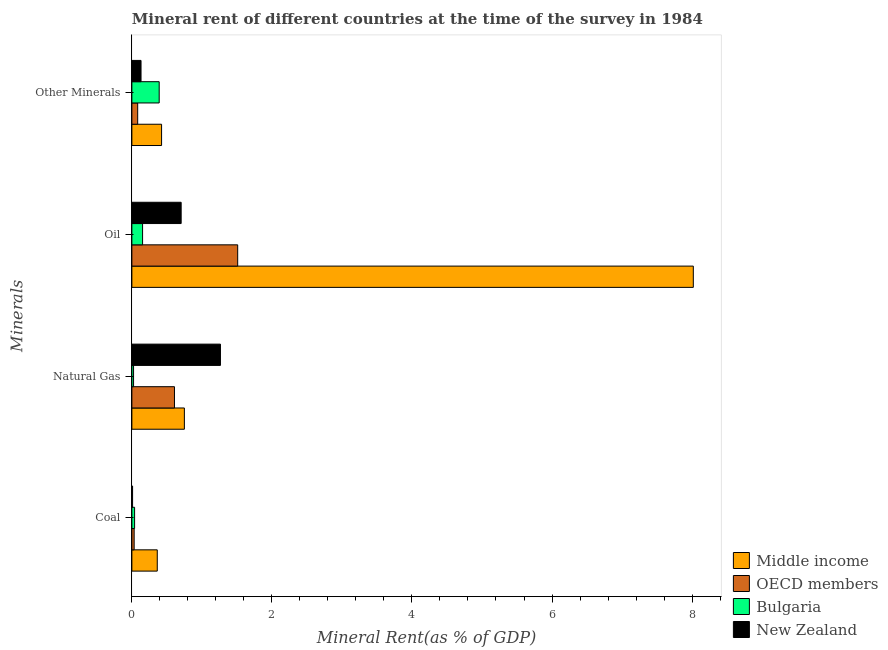How many different coloured bars are there?
Provide a short and direct response. 4. How many groups of bars are there?
Provide a short and direct response. 4. Are the number of bars per tick equal to the number of legend labels?
Ensure brevity in your answer.  Yes. Are the number of bars on each tick of the Y-axis equal?
Offer a very short reply. Yes. What is the label of the 1st group of bars from the top?
Your answer should be compact. Other Minerals. What is the  rent of other minerals in OECD members?
Your answer should be very brief. 0.08. Across all countries, what is the maximum coal rent?
Give a very brief answer. 0.36. Across all countries, what is the minimum  rent of other minerals?
Ensure brevity in your answer.  0.08. In which country was the natural gas rent maximum?
Ensure brevity in your answer.  New Zealand. In which country was the oil rent minimum?
Keep it short and to the point. Bulgaria. What is the total oil rent in the graph?
Offer a terse response. 10.39. What is the difference between the natural gas rent in Bulgaria and that in New Zealand?
Give a very brief answer. -1.24. What is the difference between the oil rent in OECD members and the natural gas rent in New Zealand?
Offer a terse response. 0.25. What is the average coal rent per country?
Provide a short and direct response. 0.11. What is the difference between the natural gas rent and coal rent in OECD members?
Provide a short and direct response. 0.58. What is the ratio of the oil rent in OECD members to that in New Zealand?
Give a very brief answer. 2.15. Is the natural gas rent in New Zealand less than that in Middle income?
Make the answer very short. No. Is the difference between the oil rent in Bulgaria and New Zealand greater than the difference between the natural gas rent in Bulgaria and New Zealand?
Offer a very short reply. Yes. What is the difference between the highest and the second highest coal rent?
Your response must be concise. 0.32. What is the difference between the highest and the lowest oil rent?
Offer a very short reply. 7.87. What does the 1st bar from the top in Oil represents?
Make the answer very short. New Zealand. Is it the case that in every country, the sum of the coal rent and natural gas rent is greater than the oil rent?
Provide a short and direct response. No. How many countries are there in the graph?
Your response must be concise. 4. Does the graph contain grids?
Your response must be concise. No. Where does the legend appear in the graph?
Give a very brief answer. Bottom right. How many legend labels are there?
Your answer should be very brief. 4. What is the title of the graph?
Provide a succinct answer. Mineral rent of different countries at the time of the survey in 1984. What is the label or title of the X-axis?
Provide a short and direct response. Mineral Rent(as % of GDP). What is the label or title of the Y-axis?
Your answer should be compact. Minerals. What is the Mineral Rent(as % of GDP) of Middle income in Coal?
Your answer should be very brief. 0.36. What is the Mineral Rent(as % of GDP) of OECD members in Coal?
Provide a short and direct response. 0.03. What is the Mineral Rent(as % of GDP) in Bulgaria in Coal?
Provide a succinct answer. 0.04. What is the Mineral Rent(as % of GDP) in New Zealand in Coal?
Make the answer very short. 0.01. What is the Mineral Rent(as % of GDP) in Middle income in Natural Gas?
Provide a succinct answer. 0.75. What is the Mineral Rent(as % of GDP) of OECD members in Natural Gas?
Your answer should be very brief. 0.61. What is the Mineral Rent(as % of GDP) in Bulgaria in Natural Gas?
Your answer should be very brief. 0.02. What is the Mineral Rent(as % of GDP) of New Zealand in Natural Gas?
Ensure brevity in your answer.  1.26. What is the Mineral Rent(as % of GDP) in Middle income in Oil?
Keep it short and to the point. 8.02. What is the Mineral Rent(as % of GDP) in OECD members in Oil?
Give a very brief answer. 1.51. What is the Mineral Rent(as % of GDP) of Bulgaria in Oil?
Provide a succinct answer. 0.15. What is the Mineral Rent(as % of GDP) in New Zealand in Oil?
Make the answer very short. 0.7. What is the Mineral Rent(as % of GDP) in Middle income in Other Minerals?
Keep it short and to the point. 0.42. What is the Mineral Rent(as % of GDP) in OECD members in Other Minerals?
Offer a very short reply. 0.08. What is the Mineral Rent(as % of GDP) of Bulgaria in Other Minerals?
Keep it short and to the point. 0.39. What is the Mineral Rent(as % of GDP) of New Zealand in Other Minerals?
Ensure brevity in your answer.  0.13. Across all Minerals, what is the maximum Mineral Rent(as % of GDP) in Middle income?
Your response must be concise. 8.02. Across all Minerals, what is the maximum Mineral Rent(as % of GDP) in OECD members?
Offer a very short reply. 1.51. Across all Minerals, what is the maximum Mineral Rent(as % of GDP) in Bulgaria?
Keep it short and to the point. 0.39. Across all Minerals, what is the maximum Mineral Rent(as % of GDP) in New Zealand?
Ensure brevity in your answer.  1.26. Across all Minerals, what is the minimum Mineral Rent(as % of GDP) in Middle income?
Offer a very short reply. 0.36. Across all Minerals, what is the minimum Mineral Rent(as % of GDP) of OECD members?
Give a very brief answer. 0.03. Across all Minerals, what is the minimum Mineral Rent(as % of GDP) in Bulgaria?
Your response must be concise. 0.02. Across all Minerals, what is the minimum Mineral Rent(as % of GDP) of New Zealand?
Keep it short and to the point. 0.01. What is the total Mineral Rent(as % of GDP) of Middle income in the graph?
Provide a succinct answer. 9.55. What is the total Mineral Rent(as % of GDP) in OECD members in the graph?
Offer a very short reply. 2.24. What is the total Mineral Rent(as % of GDP) in Bulgaria in the graph?
Keep it short and to the point. 0.61. What is the total Mineral Rent(as % of GDP) in New Zealand in the graph?
Ensure brevity in your answer.  2.11. What is the difference between the Mineral Rent(as % of GDP) in Middle income in Coal and that in Natural Gas?
Offer a very short reply. -0.39. What is the difference between the Mineral Rent(as % of GDP) of OECD members in Coal and that in Natural Gas?
Offer a terse response. -0.58. What is the difference between the Mineral Rent(as % of GDP) of Bulgaria in Coal and that in Natural Gas?
Provide a short and direct response. 0.01. What is the difference between the Mineral Rent(as % of GDP) in New Zealand in Coal and that in Natural Gas?
Your answer should be compact. -1.25. What is the difference between the Mineral Rent(as % of GDP) in Middle income in Coal and that in Oil?
Your answer should be compact. -7.66. What is the difference between the Mineral Rent(as % of GDP) of OECD members in Coal and that in Oil?
Your answer should be compact. -1.48. What is the difference between the Mineral Rent(as % of GDP) of Bulgaria in Coal and that in Oil?
Your response must be concise. -0.11. What is the difference between the Mineral Rent(as % of GDP) in New Zealand in Coal and that in Oil?
Your answer should be very brief. -0.69. What is the difference between the Mineral Rent(as % of GDP) of Middle income in Coal and that in Other Minerals?
Offer a terse response. -0.06. What is the difference between the Mineral Rent(as % of GDP) in OECD members in Coal and that in Other Minerals?
Ensure brevity in your answer.  -0.05. What is the difference between the Mineral Rent(as % of GDP) of Bulgaria in Coal and that in Other Minerals?
Provide a short and direct response. -0.35. What is the difference between the Mineral Rent(as % of GDP) in New Zealand in Coal and that in Other Minerals?
Provide a succinct answer. -0.12. What is the difference between the Mineral Rent(as % of GDP) of Middle income in Natural Gas and that in Oil?
Provide a succinct answer. -7.27. What is the difference between the Mineral Rent(as % of GDP) of OECD members in Natural Gas and that in Oil?
Make the answer very short. -0.9. What is the difference between the Mineral Rent(as % of GDP) of Bulgaria in Natural Gas and that in Oil?
Provide a succinct answer. -0.13. What is the difference between the Mineral Rent(as % of GDP) in New Zealand in Natural Gas and that in Oil?
Your response must be concise. 0.56. What is the difference between the Mineral Rent(as % of GDP) of Middle income in Natural Gas and that in Other Minerals?
Ensure brevity in your answer.  0.33. What is the difference between the Mineral Rent(as % of GDP) in OECD members in Natural Gas and that in Other Minerals?
Keep it short and to the point. 0.53. What is the difference between the Mineral Rent(as % of GDP) of Bulgaria in Natural Gas and that in Other Minerals?
Ensure brevity in your answer.  -0.37. What is the difference between the Mineral Rent(as % of GDP) in New Zealand in Natural Gas and that in Other Minerals?
Your response must be concise. 1.13. What is the difference between the Mineral Rent(as % of GDP) in Middle income in Oil and that in Other Minerals?
Provide a short and direct response. 7.59. What is the difference between the Mineral Rent(as % of GDP) in OECD members in Oil and that in Other Minerals?
Offer a very short reply. 1.43. What is the difference between the Mineral Rent(as % of GDP) in Bulgaria in Oil and that in Other Minerals?
Provide a short and direct response. -0.24. What is the difference between the Mineral Rent(as % of GDP) in New Zealand in Oil and that in Other Minerals?
Your answer should be compact. 0.57. What is the difference between the Mineral Rent(as % of GDP) in Middle income in Coal and the Mineral Rent(as % of GDP) in OECD members in Natural Gas?
Ensure brevity in your answer.  -0.25. What is the difference between the Mineral Rent(as % of GDP) in Middle income in Coal and the Mineral Rent(as % of GDP) in Bulgaria in Natural Gas?
Your answer should be very brief. 0.34. What is the difference between the Mineral Rent(as % of GDP) in Middle income in Coal and the Mineral Rent(as % of GDP) in New Zealand in Natural Gas?
Provide a short and direct response. -0.9. What is the difference between the Mineral Rent(as % of GDP) of OECD members in Coal and the Mineral Rent(as % of GDP) of Bulgaria in Natural Gas?
Offer a terse response. 0.01. What is the difference between the Mineral Rent(as % of GDP) of OECD members in Coal and the Mineral Rent(as % of GDP) of New Zealand in Natural Gas?
Offer a terse response. -1.23. What is the difference between the Mineral Rent(as % of GDP) in Bulgaria in Coal and the Mineral Rent(as % of GDP) in New Zealand in Natural Gas?
Provide a short and direct response. -1.23. What is the difference between the Mineral Rent(as % of GDP) in Middle income in Coal and the Mineral Rent(as % of GDP) in OECD members in Oil?
Offer a terse response. -1.15. What is the difference between the Mineral Rent(as % of GDP) of Middle income in Coal and the Mineral Rent(as % of GDP) of Bulgaria in Oil?
Provide a short and direct response. 0.21. What is the difference between the Mineral Rent(as % of GDP) of Middle income in Coal and the Mineral Rent(as % of GDP) of New Zealand in Oil?
Offer a terse response. -0.34. What is the difference between the Mineral Rent(as % of GDP) of OECD members in Coal and the Mineral Rent(as % of GDP) of Bulgaria in Oil?
Offer a very short reply. -0.12. What is the difference between the Mineral Rent(as % of GDP) of OECD members in Coal and the Mineral Rent(as % of GDP) of New Zealand in Oil?
Your response must be concise. -0.67. What is the difference between the Mineral Rent(as % of GDP) in Bulgaria in Coal and the Mineral Rent(as % of GDP) in New Zealand in Oil?
Provide a succinct answer. -0.66. What is the difference between the Mineral Rent(as % of GDP) in Middle income in Coal and the Mineral Rent(as % of GDP) in OECD members in Other Minerals?
Ensure brevity in your answer.  0.28. What is the difference between the Mineral Rent(as % of GDP) of Middle income in Coal and the Mineral Rent(as % of GDP) of Bulgaria in Other Minerals?
Offer a terse response. -0.03. What is the difference between the Mineral Rent(as % of GDP) in Middle income in Coal and the Mineral Rent(as % of GDP) in New Zealand in Other Minerals?
Your answer should be very brief. 0.23. What is the difference between the Mineral Rent(as % of GDP) of OECD members in Coal and the Mineral Rent(as % of GDP) of Bulgaria in Other Minerals?
Offer a terse response. -0.36. What is the difference between the Mineral Rent(as % of GDP) in OECD members in Coal and the Mineral Rent(as % of GDP) in New Zealand in Other Minerals?
Offer a very short reply. -0.1. What is the difference between the Mineral Rent(as % of GDP) of Bulgaria in Coal and the Mineral Rent(as % of GDP) of New Zealand in Other Minerals?
Offer a terse response. -0.09. What is the difference between the Mineral Rent(as % of GDP) in Middle income in Natural Gas and the Mineral Rent(as % of GDP) in OECD members in Oil?
Your response must be concise. -0.76. What is the difference between the Mineral Rent(as % of GDP) of Middle income in Natural Gas and the Mineral Rent(as % of GDP) of Bulgaria in Oil?
Provide a succinct answer. 0.6. What is the difference between the Mineral Rent(as % of GDP) of Middle income in Natural Gas and the Mineral Rent(as % of GDP) of New Zealand in Oil?
Your answer should be very brief. 0.05. What is the difference between the Mineral Rent(as % of GDP) of OECD members in Natural Gas and the Mineral Rent(as % of GDP) of Bulgaria in Oil?
Keep it short and to the point. 0.46. What is the difference between the Mineral Rent(as % of GDP) of OECD members in Natural Gas and the Mineral Rent(as % of GDP) of New Zealand in Oil?
Keep it short and to the point. -0.1. What is the difference between the Mineral Rent(as % of GDP) of Bulgaria in Natural Gas and the Mineral Rent(as % of GDP) of New Zealand in Oil?
Your answer should be very brief. -0.68. What is the difference between the Mineral Rent(as % of GDP) in Middle income in Natural Gas and the Mineral Rent(as % of GDP) in OECD members in Other Minerals?
Ensure brevity in your answer.  0.67. What is the difference between the Mineral Rent(as % of GDP) of Middle income in Natural Gas and the Mineral Rent(as % of GDP) of Bulgaria in Other Minerals?
Give a very brief answer. 0.36. What is the difference between the Mineral Rent(as % of GDP) in Middle income in Natural Gas and the Mineral Rent(as % of GDP) in New Zealand in Other Minerals?
Your answer should be compact. 0.62. What is the difference between the Mineral Rent(as % of GDP) of OECD members in Natural Gas and the Mineral Rent(as % of GDP) of Bulgaria in Other Minerals?
Give a very brief answer. 0.22. What is the difference between the Mineral Rent(as % of GDP) of OECD members in Natural Gas and the Mineral Rent(as % of GDP) of New Zealand in Other Minerals?
Offer a very short reply. 0.48. What is the difference between the Mineral Rent(as % of GDP) of Bulgaria in Natural Gas and the Mineral Rent(as % of GDP) of New Zealand in Other Minerals?
Give a very brief answer. -0.11. What is the difference between the Mineral Rent(as % of GDP) in Middle income in Oil and the Mineral Rent(as % of GDP) in OECD members in Other Minerals?
Offer a very short reply. 7.94. What is the difference between the Mineral Rent(as % of GDP) of Middle income in Oil and the Mineral Rent(as % of GDP) of Bulgaria in Other Minerals?
Your response must be concise. 7.63. What is the difference between the Mineral Rent(as % of GDP) of Middle income in Oil and the Mineral Rent(as % of GDP) of New Zealand in Other Minerals?
Make the answer very short. 7.89. What is the difference between the Mineral Rent(as % of GDP) of OECD members in Oil and the Mineral Rent(as % of GDP) of Bulgaria in Other Minerals?
Offer a terse response. 1.12. What is the difference between the Mineral Rent(as % of GDP) in OECD members in Oil and the Mineral Rent(as % of GDP) in New Zealand in Other Minerals?
Give a very brief answer. 1.38. What is the difference between the Mineral Rent(as % of GDP) of Bulgaria in Oil and the Mineral Rent(as % of GDP) of New Zealand in Other Minerals?
Ensure brevity in your answer.  0.02. What is the average Mineral Rent(as % of GDP) of Middle income per Minerals?
Offer a terse response. 2.39. What is the average Mineral Rent(as % of GDP) of OECD members per Minerals?
Provide a succinct answer. 0.56. What is the average Mineral Rent(as % of GDP) of Bulgaria per Minerals?
Make the answer very short. 0.15. What is the average Mineral Rent(as % of GDP) of New Zealand per Minerals?
Your answer should be very brief. 0.53. What is the difference between the Mineral Rent(as % of GDP) in Middle income and Mineral Rent(as % of GDP) in OECD members in Coal?
Provide a succinct answer. 0.33. What is the difference between the Mineral Rent(as % of GDP) in Middle income and Mineral Rent(as % of GDP) in Bulgaria in Coal?
Your answer should be very brief. 0.32. What is the difference between the Mineral Rent(as % of GDP) of Middle income and Mineral Rent(as % of GDP) of New Zealand in Coal?
Keep it short and to the point. 0.35. What is the difference between the Mineral Rent(as % of GDP) of OECD members and Mineral Rent(as % of GDP) of Bulgaria in Coal?
Keep it short and to the point. -0.01. What is the difference between the Mineral Rent(as % of GDP) in OECD members and Mineral Rent(as % of GDP) in New Zealand in Coal?
Keep it short and to the point. 0.02. What is the difference between the Mineral Rent(as % of GDP) in Bulgaria and Mineral Rent(as % of GDP) in New Zealand in Coal?
Provide a succinct answer. 0.03. What is the difference between the Mineral Rent(as % of GDP) of Middle income and Mineral Rent(as % of GDP) of OECD members in Natural Gas?
Your answer should be compact. 0.14. What is the difference between the Mineral Rent(as % of GDP) of Middle income and Mineral Rent(as % of GDP) of Bulgaria in Natural Gas?
Provide a short and direct response. 0.73. What is the difference between the Mineral Rent(as % of GDP) in Middle income and Mineral Rent(as % of GDP) in New Zealand in Natural Gas?
Provide a short and direct response. -0.52. What is the difference between the Mineral Rent(as % of GDP) of OECD members and Mineral Rent(as % of GDP) of Bulgaria in Natural Gas?
Give a very brief answer. 0.58. What is the difference between the Mineral Rent(as % of GDP) of OECD members and Mineral Rent(as % of GDP) of New Zealand in Natural Gas?
Provide a short and direct response. -0.66. What is the difference between the Mineral Rent(as % of GDP) of Bulgaria and Mineral Rent(as % of GDP) of New Zealand in Natural Gas?
Ensure brevity in your answer.  -1.24. What is the difference between the Mineral Rent(as % of GDP) in Middle income and Mineral Rent(as % of GDP) in OECD members in Oil?
Offer a very short reply. 6.51. What is the difference between the Mineral Rent(as % of GDP) in Middle income and Mineral Rent(as % of GDP) in Bulgaria in Oil?
Your answer should be compact. 7.87. What is the difference between the Mineral Rent(as % of GDP) of Middle income and Mineral Rent(as % of GDP) of New Zealand in Oil?
Your response must be concise. 7.31. What is the difference between the Mineral Rent(as % of GDP) in OECD members and Mineral Rent(as % of GDP) in Bulgaria in Oil?
Your response must be concise. 1.36. What is the difference between the Mineral Rent(as % of GDP) in OECD members and Mineral Rent(as % of GDP) in New Zealand in Oil?
Your answer should be compact. 0.81. What is the difference between the Mineral Rent(as % of GDP) in Bulgaria and Mineral Rent(as % of GDP) in New Zealand in Oil?
Your answer should be very brief. -0.55. What is the difference between the Mineral Rent(as % of GDP) in Middle income and Mineral Rent(as % of GDP) in OECD members in Other Minerals?
Offer a very short reply. 0.34. What is the difference between the Mineral Rent(as % of GDP) in Middle income and Mineral Rent(as % of GDP) in Bulgaria in Other Minerals?
Your answer should be very brief. 0.03. What is the difference between the Mineral Rent(as % of GDP) of Middle income and Mineral Rent(as % of GDP) of New Zealand in Other Minerals?
Keep it short and to the point. 0.29. What is the difference between the Mineral Rent(as % of GDP) of OECD members and Mineral Rent(as % of GDP) of Bulgaria in Other Minerals?
Offer a terse response. -0.31. What is the difference between the Mineral Rent(as % of GDP) in OECD members and Mineral Rent(as % of GDP) in New Zealand in Other Minerals?
Make the answer very short. -0.05. What is the difference between the Mineral Rent(as % of GDP) in Bulgaria and Mineral Rent(as % of GDP) in New Zealand in Other Minerals?
Keep it short and to the point. 0.26. What is the ratio of the Mineral Rent(as % of GDP) of Middle income in Coal to that in Natural Gas?
Offer a very short reply. 0.48. What is the ratio of the Mineral Rent(as % of GDP) in OECD members in Coal to that in Natural Gas?
Your answer should be compact. 0.05. What is the ratio of the Mineral Rent(as % of GDP) of Bulgaria in Coal to that in Natural Gas?
Offer a very short reply. 1.61. What is the ratio of the Mineral Rent(as % of GDP) of New Zealand in Coal to that in Natural Gas?
Your answer should be compact. 0.01. What is the ratio of the Mineral Rent(as % of GDP) in Middle income in Coal to that in Oil?
Provide a succinct answer. 0.05. What is the ratio of the Mineral Rent(as % of GDP) of OECD members in Coal to that in Oil?
Ensure brevity in your answer.  0.02. What is the ratio of the Mineral Rent(as % of GDP) in Bulgaria in Coal to that in Oil?
Offer a very short reply. 0.25. What is the ratio of the Mineral Rent(as % of GDP) of New Zealand in Coal to that in Oil?
Provide a succinct answer. 0.01. What is the ratio of the Mineral Rent(as % of GDP) in Middle income in Coal to that in Other Minerals?
Your response must be concise. 0.85. What is the ratio of the Mineral Rent(as % of GDP) in OECD members in Coal to that in Other Minerals?
Provide a succinct answer. 0.39. What is the ratio of the Mineral Rent(as % of GDP) in Bulgaria in Coal to that in Other Minerals?
Make the answer very short. 0.1. What is the ratio of the Mineral Rent(as % of GDP) of New Zealand in Coal to that in Other Minerals?
Keep it short and to the point. 0.08. What is the ratio of the Mineral Rent(as % of GDP) in Middle income in Natural Gas to that in Oil?
Give a very brief answer. 0.09. What is the ratio of the Mineral Rent(as % of GDP) in OECD members in Natural Gas to that in Oil?
Your answer should be very brief. 0.4. What is the ratio of the Mineral Rent(as % of GDP) of Bulgaria in Natural Gas to that in Oil?
Your answer should be compact. 0.16. What is the ratio of the Mineral Rent(as % of GDP) of New Zealand in Natural Gas to that in Oil?
Provide a short and direct response. 1.8. What is the ratio of the Mineral Rent(as % of GDP) of Middle income in Natural Gas to that in Other Minerals?
Give a very brief answer. 1.77. What is the ratio of the Mineral Rent(as % of GDP) in OECD members in Natural Gas to that in Other Minerals?
Your response must be concise. 7.33. What is the ratio of the Mineral Rent(as % of GDP) in Bulgaria in Natural Gas to that in Other Minerals?
Make the answer very short. 0.06. What is the ratio of the Mineral Rent(as % of GDP) in New Zealand in Natural Gas to that in Other Minerals?
Make the answer very short. 9.67. What is the ratio of the Mineral Rent(as % of GDP) in Middle income in Oil to that in Other Minerals?
Your response must be concise. 18.9. What is the ratio of the Mineral Rent(as % of GDP) in OECD members in Oil to that in Other Minerals?
Keep it short and to the point. 18.21. What is the ratio of the Mineral Rent(as % of GDP) of Bulgaria in Oil to that in Other Minerals?
Ensure brevity in your answer.  0.39. What is the ratio of the Mineral Rent(as % of GDP) of New Zealand in Oil to that in Other Minerals?
Give a very brief answer. 5.38. What is the difference between the highest and the second highest Mineral Rent(as % of GDP) of Middle income?
Provide a succinct answer. 7.27. What is the difference between the highest and the second highest Mineral Rent(as % of GDP) in OECD members?
Provide a short and direct response. 0.9. What is the difference between the highest and the second highest Mineral Rent(as % of GDP) in Bulgaria?
Provide a succinct answer. 0.24. What is the difference between the highest and the second highest Mineral Rent(as % of GDP) of New Zealand?
Give a very brief answer. 0.56. What is the difference between the highest and the lowest Mineral Rent(as % of GDP) in Middle income?
Give a very brief answer. 7.66. What is the difference between the highest and the lowest Mineral Rent(as % of GDP) in OECD members?
Provide a succinct answer. 1.48. What is the difference between the highest and the lowest Mineral Rent(as % of GDP) in Bulgaria?
Make the answer very short. 0.37. What is the difference between the highest and the lowest Mineral Rent(as % of GDP) of New Zealand?
Your answer should be very brief. 1.25. 